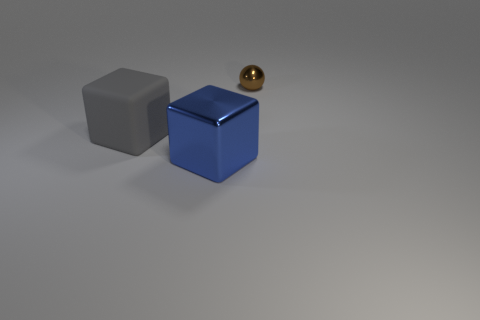Is there any other thing that has the same size as the brown ball?
Provide a short and direct response. No. Is there anything else that is the same shape as the brown metallic object?
Your response must be concise. No. Are any large blue objects visible?
Offer a very short reply. Yes. What number of objects are big blocks behind the large blue cube or shiny things on the left side of the brown thing?
Your response must be concise. 2. Is the color of the metal sphere the same as the matte block?
Provide a succinct answer. No. Is the number of tiny brown shiny blocks less than the number of small brown shiny balls?
Offer a very short reply. Yes. Are there any things left of the small brown metal sphere?
Keep it short and to the point. Yes. Does the tiny brown ball have the same material as the large gray cube?
Ensure brevity in your answer.  No. The other big object that is the same shape as the blue object is what color?
Keep it short and to the point. Gray. Do the metallic thing that is to the left of the ball and the metal sphere have the same color?
Your response must be concise. No. 